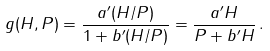Convert formula to latex. <formula><loc_0><loc_0><loc_500><loc_500>g ( H , P ) = \frac { a ^ { \prime } ( H / P ) } { 1 + b ^ { \prime } ( H / P ) } = \frac { a ^ { \prime } H } { P + b ^ { \prime } H } \, .</formula> 